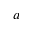<formula> <loc_0><loc_0><loc_500><loc_500>a</formula> 